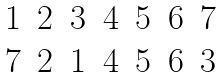Convert formula to latex. <formula><loc_0><loc_0><loc_500><loc_500>\begin{matrix} 1 & 2 & 3 & 4 & 5 & 6 & 7 \\ 7 & 2 & 1 & 4 & 5 & 6 & 3 \end{matrix}</formula> 